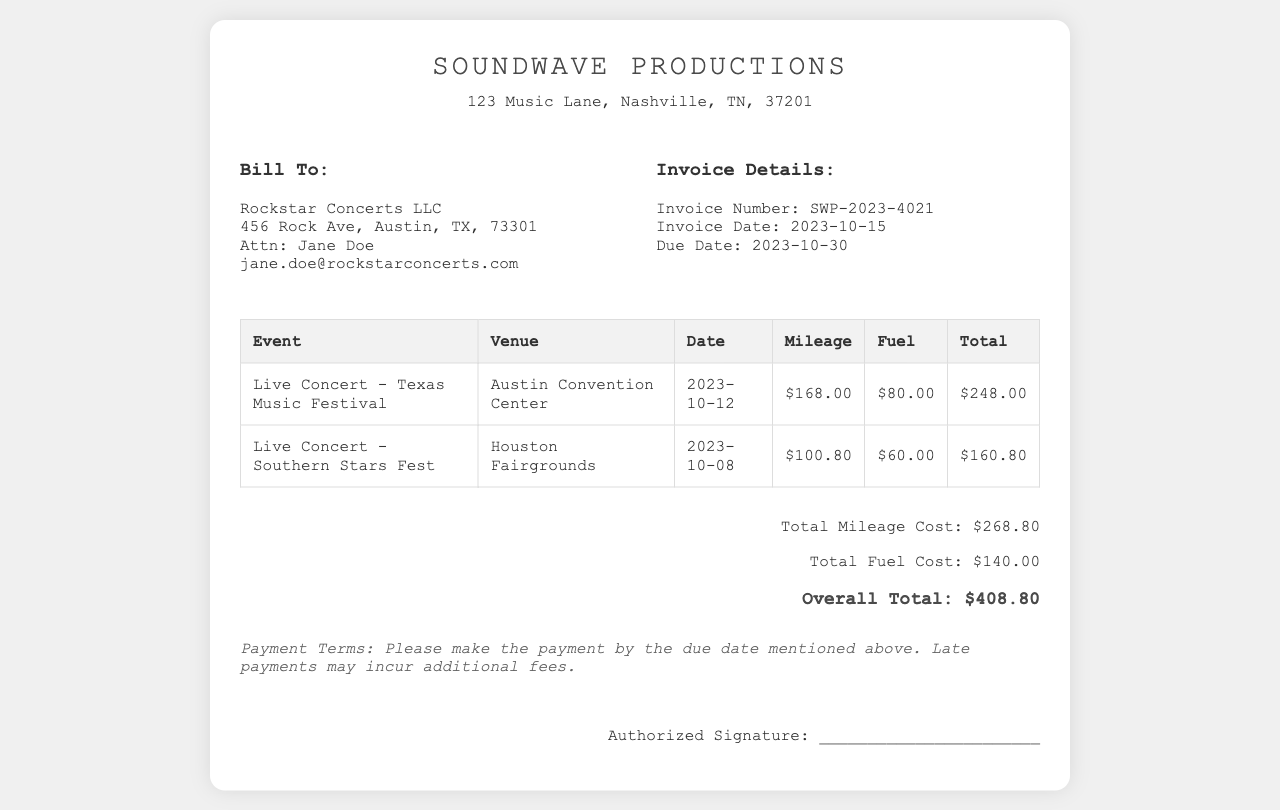What is the invoice number? The invoice number is clearly specified in the document under the invoice details section.
Answer: SWP-2023-4021 What is the due date for payment? The due date is outlined in the invoice details section, indicating when the payment needs to be completed.
Answer: 2023-10-30 What venue was used for the Southern Stars Fest? The document lists the venue associated with this particular event in the table.
Answer: Houston Fairgrounds How much was the fuel cost for the Texas Music Festival? The fuel cost for this event is specified in the respective row of the table.
Answer: $80.00 What is the total overall cost on the invoice? The overall total is provided at the bottom of the summary section.
Answer: $408.80 How many events are listed in the invoice? The number of events can be determined by counting the rows in the table.
Answer: 2 What is the total mileage cost across all events? The total mileage cost is calculated and presented in the summary section.
Answer: $268.80 What is the fuel charge for the Live Concert on October 12? The fuel charge is indicated in the respective row of the events table.
Answer: $80.00 Who is the contact person for Rockstar Concerts LLC? The contact person's name is mentioned in the client details section of the invoice.
Answer: Jane Doe 